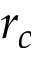<formula> <loc_0><loc_0><loc_500><loc_500>r _ { c }</formula> 